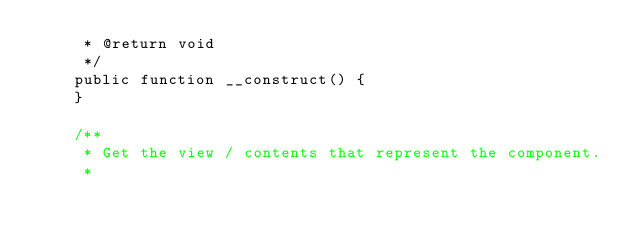Convert code to text. <code><loc_0><loc_0><loc_500><loc_500><_PHP_>     * @return void
     */
    public function __construct() {
    }

    /**
     * Get the view / contents that represent the component.
     *</code> 